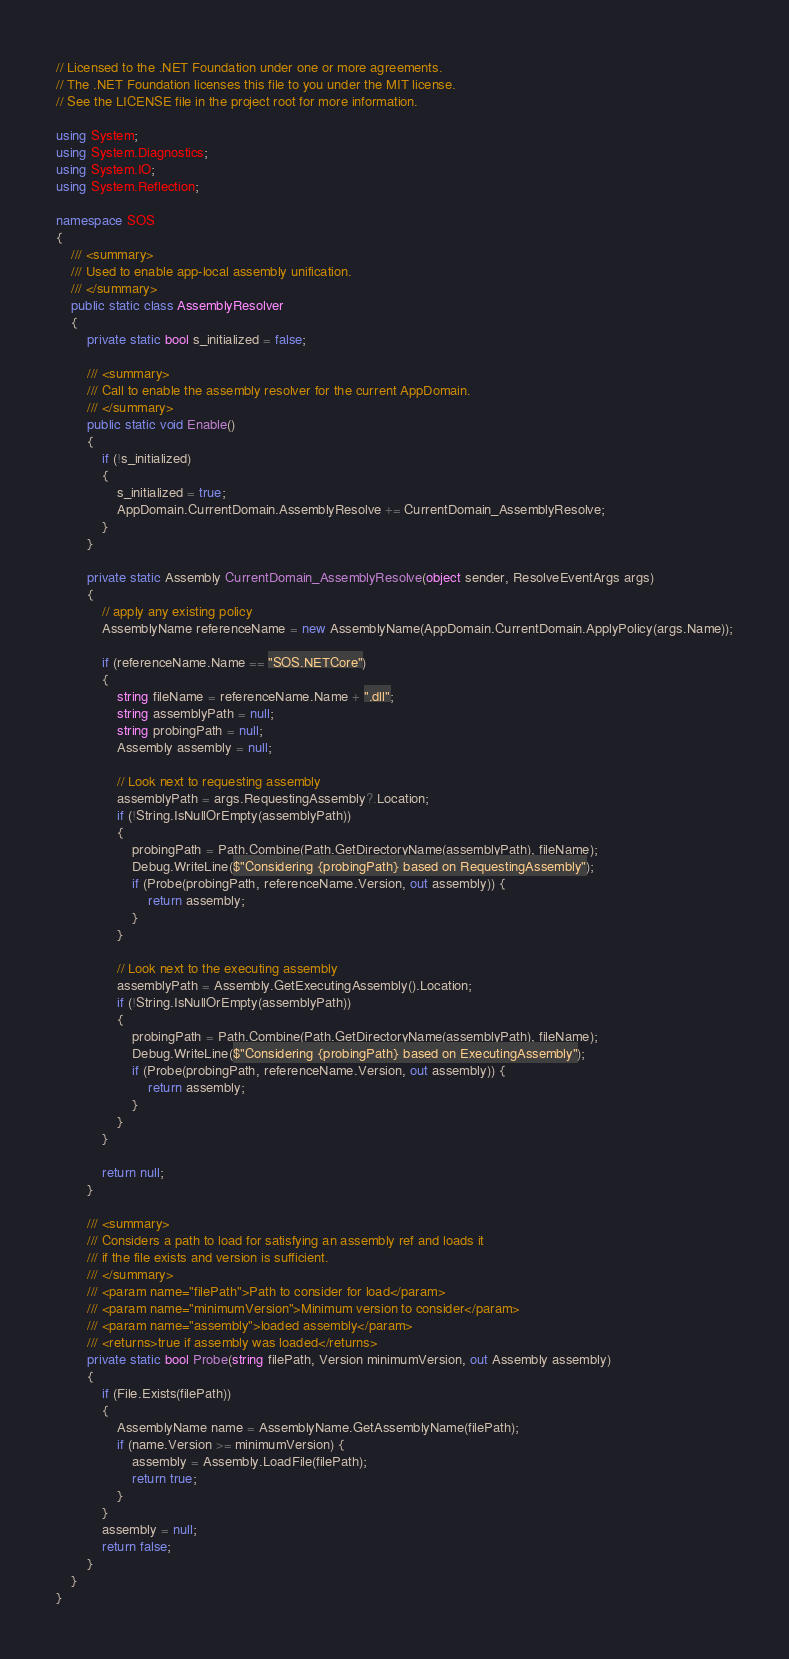<code> <loc_0><loc_0><loc_500><loc_500><_C#_>// Licensed to the .NET Foundation under one or more agreements.
// The .NET Foundation licenses this file to you under the MIT license.
// See the LICENSE file in the project root for more information.

using System;
using System.Diagnostics;
using System.IO;
using System.Reflection;

namespace SOS
{
    /// <summary>
    /// Used to enable app-local assembly unification.
    /// </summary>
    public static class AssemblyResolver
    {
        private static bool s_initialized = false;

        /// <summary>
        /// Call to enable the assembly resolver for the current AppDomain.
        /// </summary>
        public static void Enable()
        {
            if (!s_initialized)
            {
                s_initialized = true;
                AppDomain.CurrentDomain.AssemblyResolve += CurrentDomain_AssemblyResolve;
            }
        }

        private static Assembly CurrentDomain_AssemblyResolve(object sender, ResolveEventArgs args)
        {
            // apply any existing policy
            AssemblyName referenceName = new AssemblyName(AppDomain.CurrentDomain.ApplyPolicy(args.Name));

            if (referenceName.Name == "SOS.NETCore")
            {
                string fileName = referenceName.Name + ".dll";
                string assemblyPath = null;
                string probingPath = null;
                Assembly assembly = null;

                // Look next to requesting assembly
                assemblyPath = args.RequestingAssembly?.Location;
                if (!String.IsNullOrEmpty(assemblyPath))
                {
                    probingPath = Path.Combine(Path.GetDirectoryName(assemblyPath), fileName);
                    Debug.WriteLine($"Considering {probingPath} based on RequestingAssembly");
                    if (Probe(probingPath, referenceName.Version, out assembly)) {
                        return assembly;
                    }
                }

                // Look next to the executing assembly
                assemblyPath = Assembly.GetExecutingAssembly().Location;
                if (!String.IsNullOrEmpty(assemblyPath))
                {
                    probingPath = Path.Combine(Path.GetDirectoryName(assemblyPath), fileName);
                    Debug.WriteLine($"Considering {probingPath} based on ExecutingAssembly");
                    if (Probe(probingPath, referenceName.Version, out assembly)) {
                        return assembly;
                    }
                }
            }

            return null;
        }

        /// <summary>
        /// Considers a path to load for satisfying an assembly ref and loads it
        /// if the file exists and version is sufficient.
        /// </summary>
        /// <param name="filePath">Path to consider for load</param>
        /// <param name="minimumVersion">Minimum version to consider</param>
        /// <param name="assembly">loaded assembly</param>
        /// <returns>true if assembly was loaded</returns>
        private static bool Probe(string filePath, Version minimumVersion, out Assembly assembly)
        {
            if (File.Exists(filePath))
            {
                AssemblyName name = AssemblyName.GetAssemblyName(filePath);
                if (name.Version >= minimumVersion) {
                    assembly = Assembly.LoadFile(filePath);
                    return true;
                }
            }
            assembly = null;
            return false;
        }
    }
}
</code> 